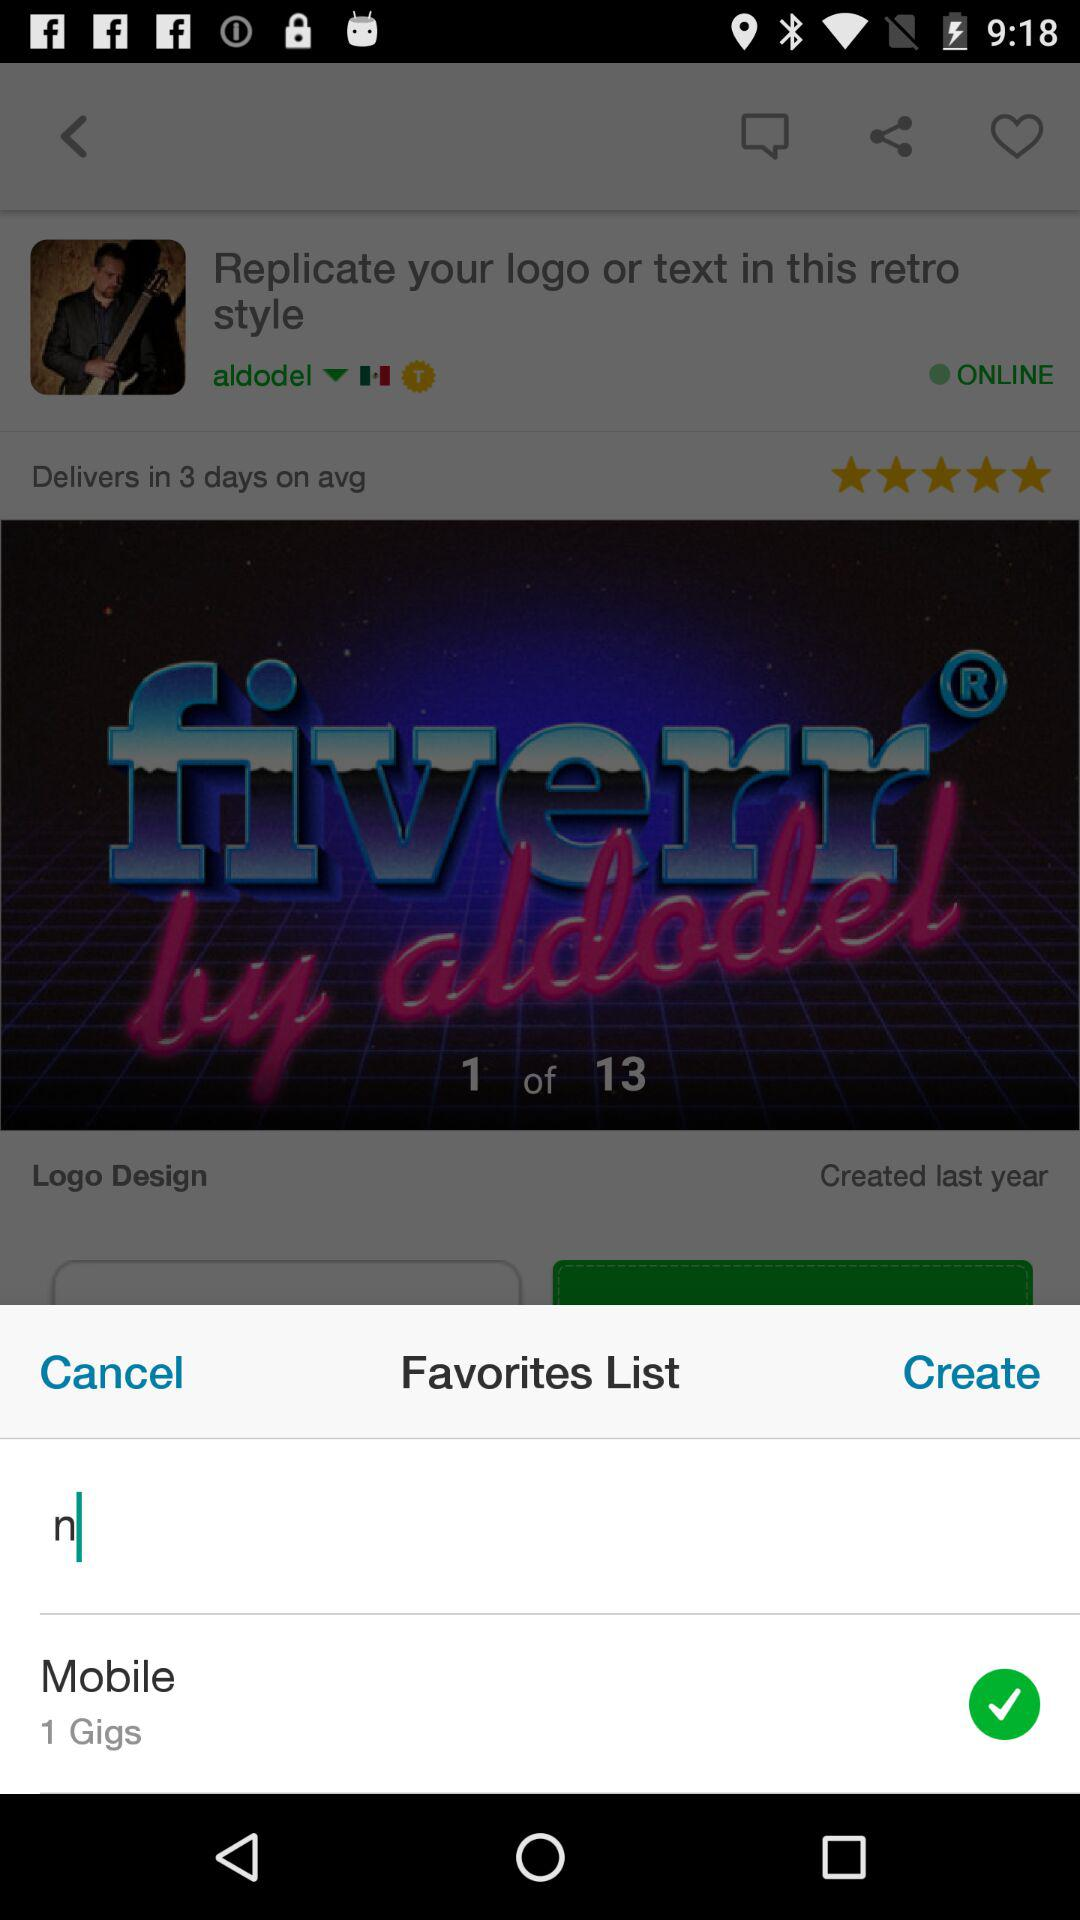How many total pages are there? There are 13 pages. 